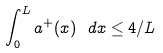Convert formula to latex. <formula><loc_0><loc_0><loc_500><loc_500>\int _ { 0 } ^ { L } a ^ { + } ( x ) \ d x \leq 4 / L</formula> 